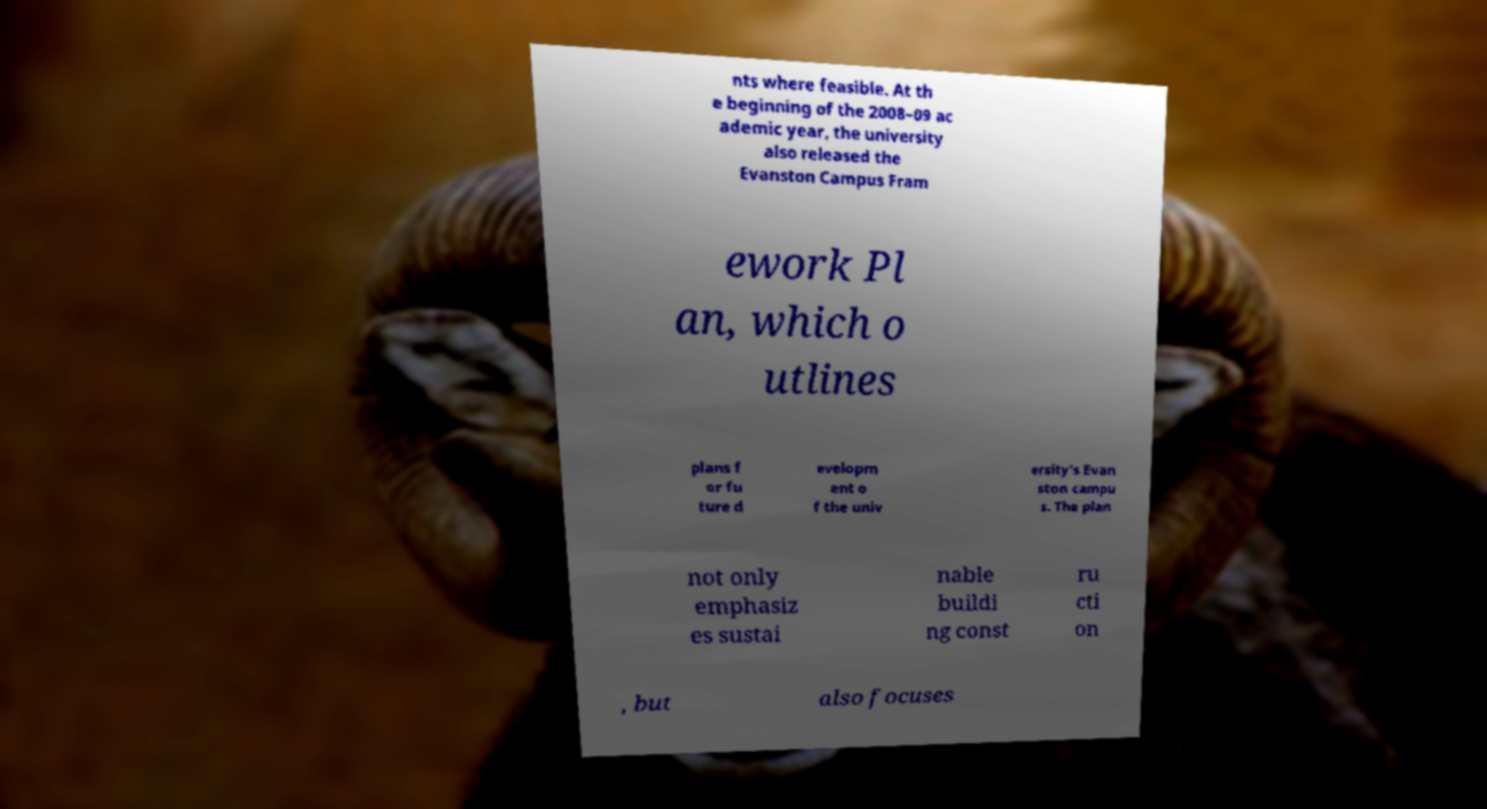Please read and relay the text visible in this image. What does it say? nts where feasible. At th e beginning of the 2008–09 ac ademic year, the university also released the Evanston Campus Fram ework Pl an, which o utlines plans f or fu ture d evelopm ent o f the univ ersity's Evan ston campu s. The plan not only emphasiz es sustai nable buildi ng const ru cti on , but also focuses 